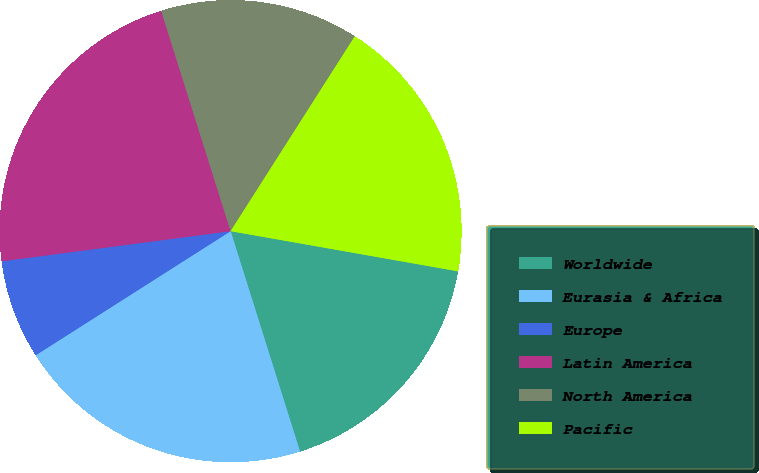Convert chart. <chart><loc_0><loc_0><loc_500><loc_500><pie_chart><fcel>Worldwide<fcel>Eurasia & Africa<fcel>Europe<fcel>Latin America<fcel>North America<fcel>Pacific<nl><fcel>17.36%<fcel>20.83%<fcel>6.94%<fcel>22.22%<fcel>13.89%<fcel>18.75%<nl></chart> 